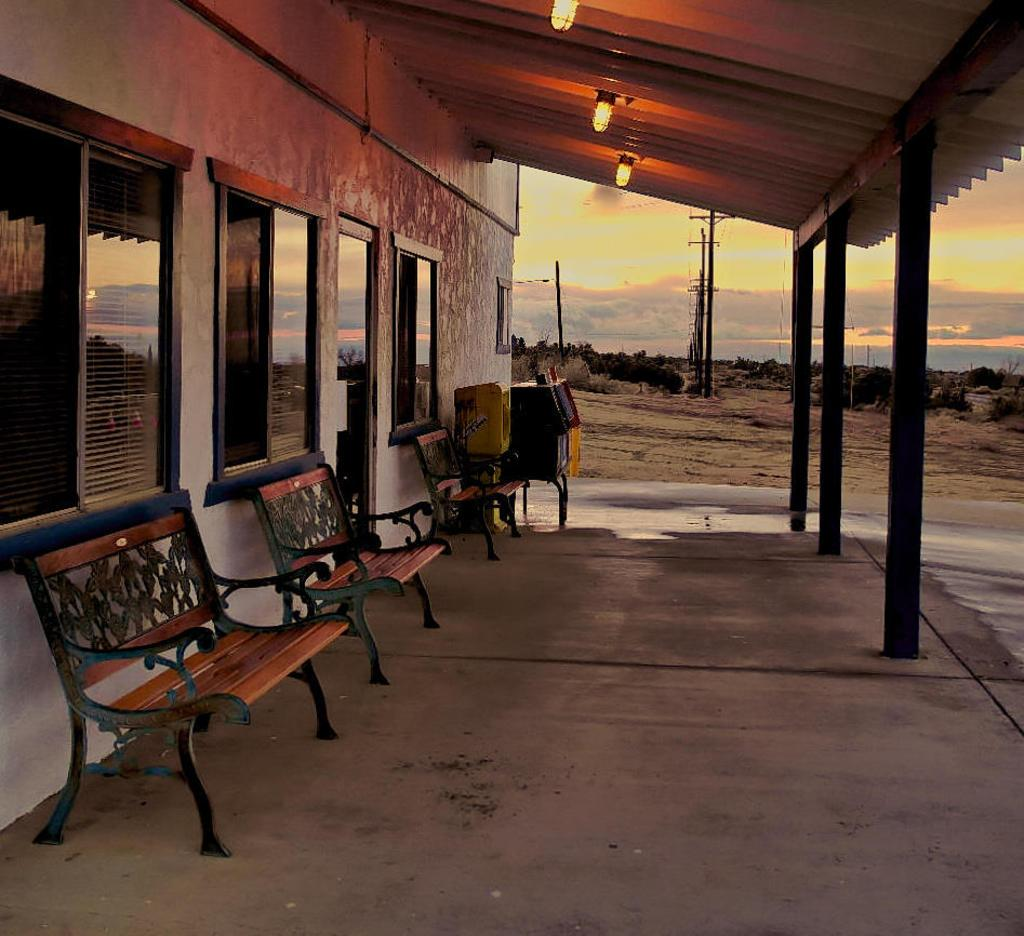What type of structure is present in the image? There is a building in the image. What features can be observed on the building? The building has windows and pillars. What type of seating is available in the image? There are benches in the image. What type of vegetation is present in the image? There are trees in the image. What type of illumination is present in the image? There are lights in the image. What type of vertical structures are present in the image? There are poles in the image. What can be seen in the background of the image? The sky is visible in the background of the image. What type of weather can be inferred from the image? There are clouds in the sky, suggesting a partly cloudy day. What type of egg is being cooked by the crook in the image? There is no crook or egg present in the image. What is your dad doing in the image? There is no reference to a dad or any person in the image, so it's not possible to answer that question. 